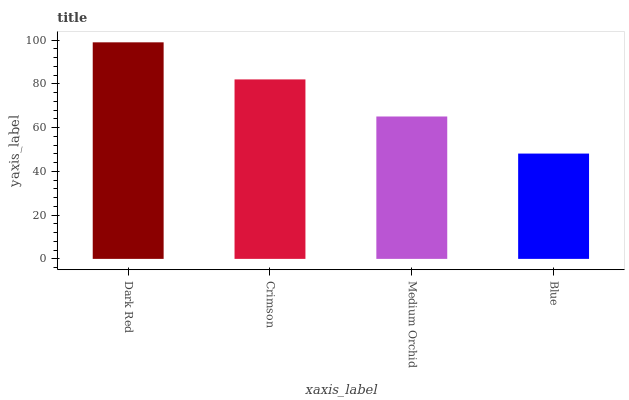Is Blue the minimum?
Answer yes or no. Yes. Is Dark Red the maximum?
Answer yes or no. Yes. Is Crimson the minimum?
Answer yes or no. No. Is Crimson the maximum?
Answer yes or no. No. Is Dark Red greater than Crimson?
Answer yes or no. Yes. Is Crimson less than Dark Red?
Answer yes or no. Yes. Is Crimson greater than Dark Red?
Answer yes or no. No. Is Dark Red less than Crimson?
Answer yes or no. No. Is Crimson the high median?
Answer yes or no. Yes. Is Medium Orchid the low median?
Answer yes or no. Yes. Is Blue the high median?
Answer yes or no. No. Is Crimson the low median?
Answer yes or no. No. 